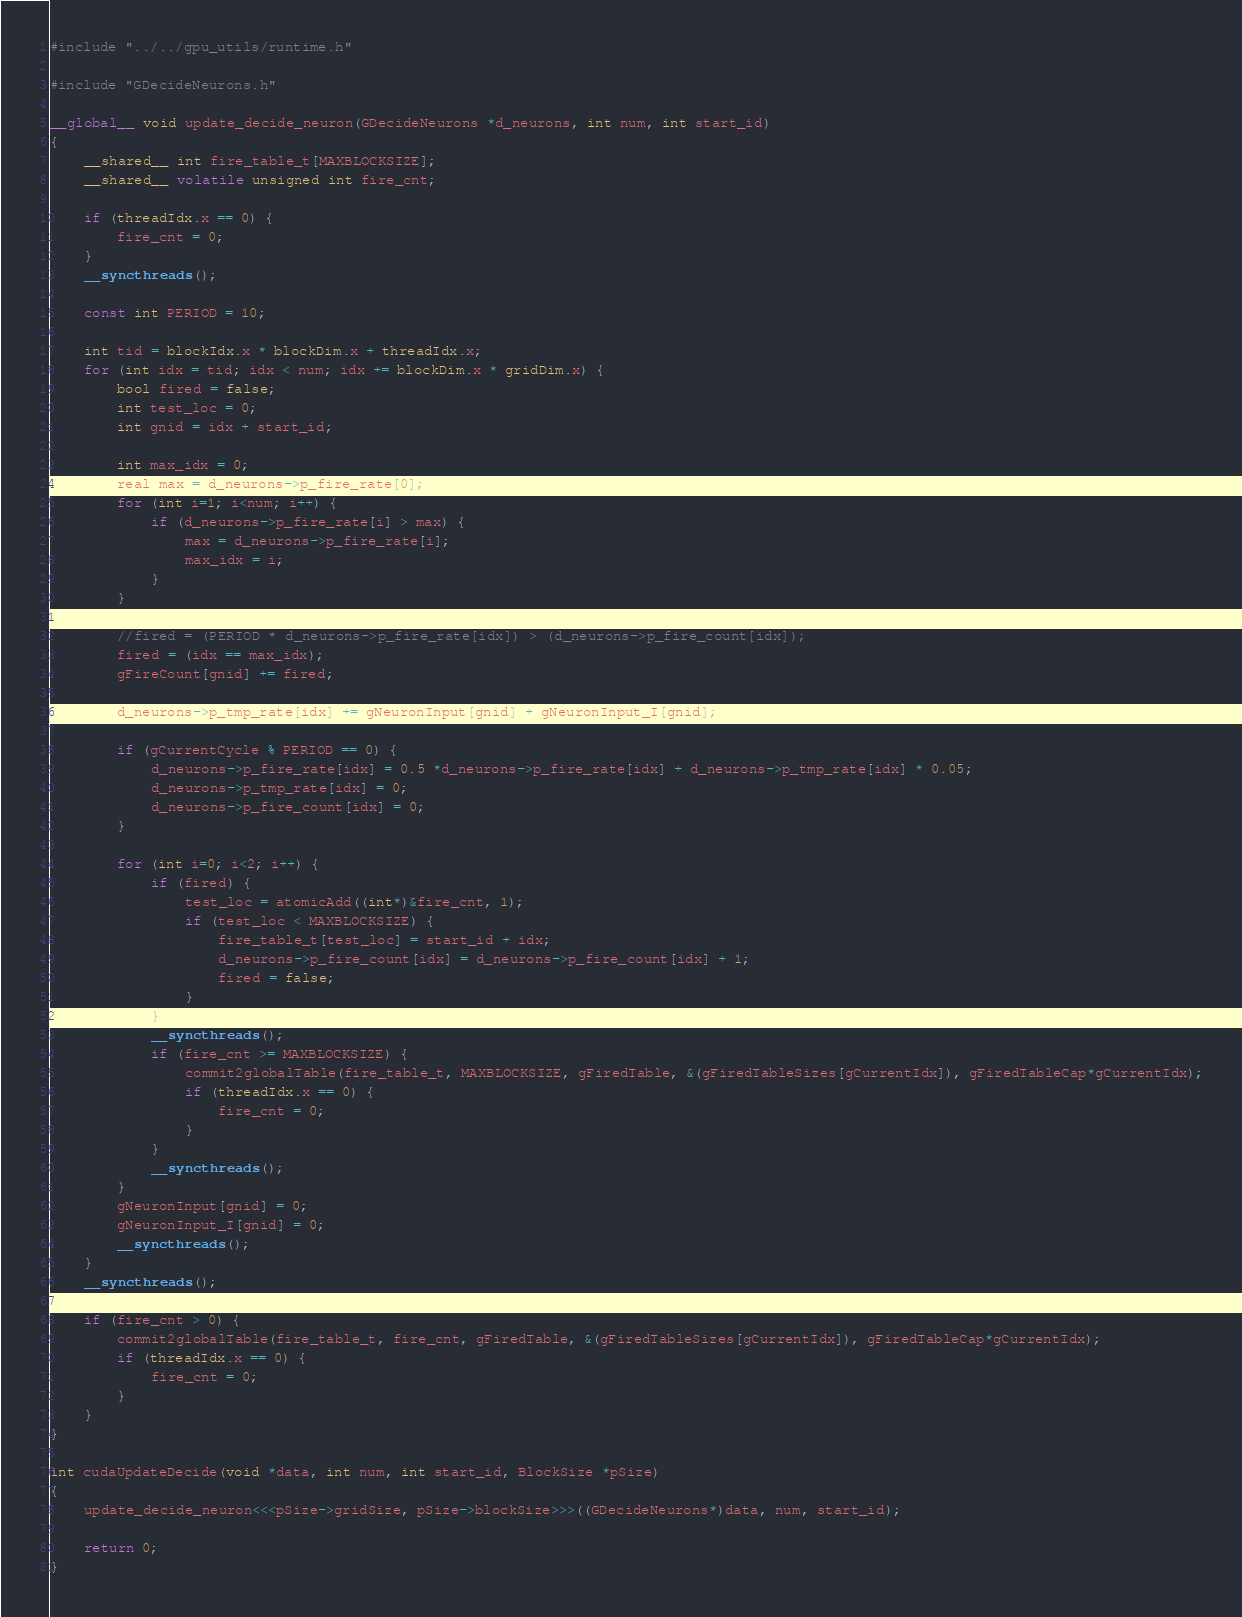Convert code to text. <code><loc_0><loc_0><loc_500><loc_500><_Cuda_>
#include "../../gpu_utils/runtime.h"

#include "GDecideNeurons.h"

__global__ void update_decide_neuron(GDecideNeurons *d_neurons, int num, int start_id)
{
	__shared__ int fire_table_t[MAXBLOCKSIZE];
	__shared__ volatile unsigned int fire_cnt;

	if (threadIdx.x == 0) {
		fire_cnt = 0;
	}
	__syncthreads();

	const int PERIOD = 10;

	int tid = blockIdx.x * blockDim.x + threadIdx.x;
	for (int idx = tid; idx < num; idx += blockDim.x * gridDim.x) {
		bool fired = false;
		int test_loc = 0;
		int gnid = idx + start_id;

		int max_idx = 0;
		real max = d_neurons->p_fire_rate[0];
		for (int i=1; i<num; i++) {
			if (d_neurons->p_fire_rate[i] > max) {
				max = d_neurons->p_fire_rate[i];
				max_idx = i;
			}
		}

		//fired = (PERIOD * d_neurons->p_fire_rate[idx]) > (d_neurons->p_fire_count[idx]);
		fired = (idx == max_idx);
		gFireCount[gnid] += fired;

		d_neurons->p_tmp_rate[idx] += gNeuronInput[gnid] + gNeuronInput_I[gnid];

		if (gCurrentCycle % PERIOD == 0) {
			d_neurons->p_fire_rate[idx] = 0.5 *d_neurons->p_fire_rate[idx] + d_neurons->p_tmp_rate[idx] * 0.05;
			d_neurons->p_tmp_rate[idx] = 0;
			d_neurons->p_fire_count[idx] = 0;
		}

		for (int i=0; i<2; i++) {
			if (fired) {
				test_loc = atomicAdd((int*)&fire_cnt, 1);
				if (test_loc < MAXBLOCKSIZE) {
					fire_table_t[test_loc] = start_id + idx;
					d_neurons->p_fire_count[idx] = d_neurons->p_fire_count[idx] + 1;
					fired = false;
				}
			}
			__syncthreads();
			if (fire_cnt >= MAXBLOCKSIZE) {
				commit2globalTable(fire_table_t, MAXBLOCKSIZE, gFiredTable, &(gFiredTableSizes[gCurrentIdx]), gFiredTableCap*gCurrentIdx);
				if (threadIdx.x == 0) {
					fire_cnt = 0;
				}
			}
			__syncthreads();
		}
		gNeuronInput[gnid] = 0;
		gNeuronInput_I[gnid] = 0;
		__syncthreads();
	}
	__syncthreads();

	if (fire_cnt > 0) {
		commit2globalTable(fire_table_t, fire_cnt, gFiredTable, &(gFiredTableSizes[gCurrentIdx]), gFiredTableCap*gCurrentIdx);
		if (threadIdx.x == 0) {
			fire_cnt = 0;
		}
	}
}

int cudaUpdateDecide(void *data, int num, int start_id, BlockSize *pSize)
{
	update_decide_neuron<<<pSize->gridSize, pSize->blockSize>>>((GDecideNeurons*)data, num, start_id);

	return 0;
}

</code> 